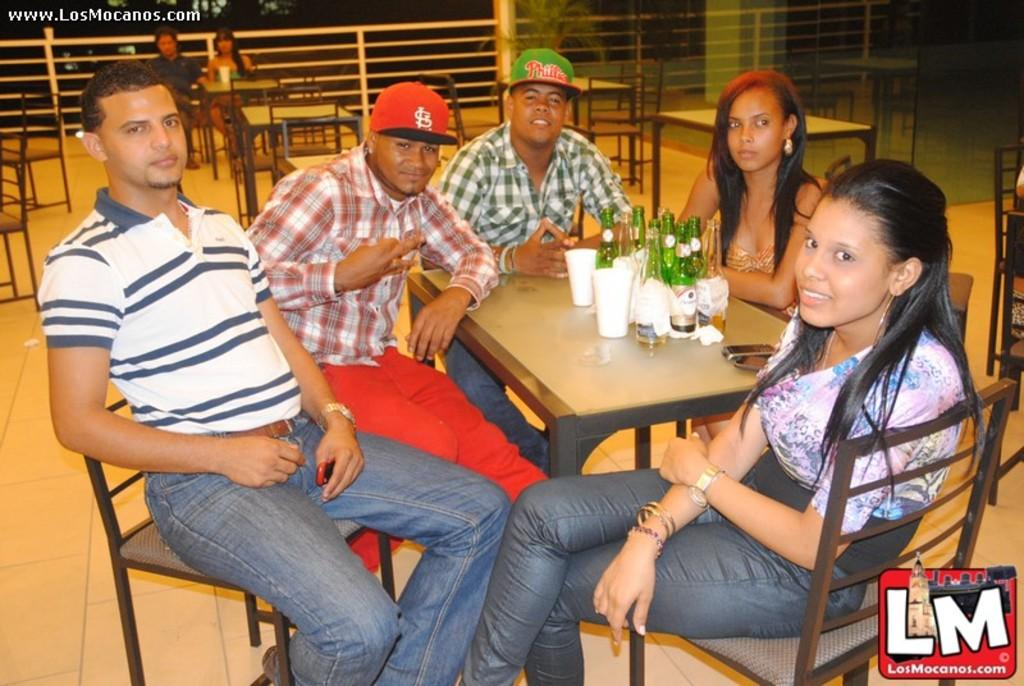What are the people in the image doing? The people in the image are sitting on chairs. What objects can be seen on the table in the image? There are bottles on a table in the image. What is the condition of the seat on the chair in the image? The condition of the seat on the chair is not mentioned in the image, so it cannot be determined. What word is written on the bottles in the image? The image does not provide information about the word written on the bottles, so it cannot be determined. 